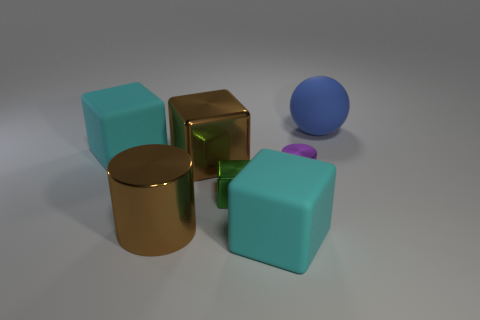Add 2 brown metal things. How many objects exist? 9 Subtract all spheres. How many objects are left? 6 Subtract 0 blue cylinders. How many objects are left? 7 Subtract all green cubes. Subtract all brown cubes. How many objects are left? 5 Add 5 large shiny objects. How many large shiny objects are left? 7 Add 7 large cyan rubber cubes. How many large cyan rubber cubes exist? 9 